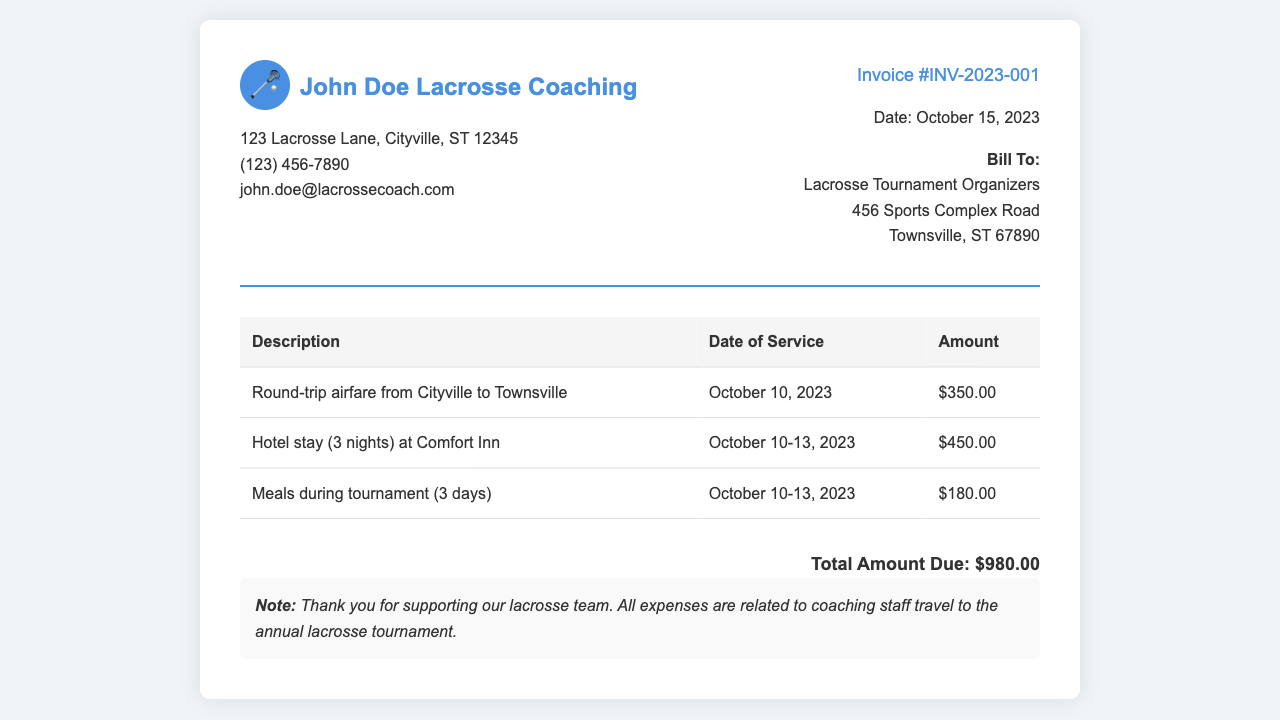What is the invoice number? The invoice number is listed near the top of the document, under the invoice details section.
Answer: INV-2023-001 What is the total amount due? The total amount due is found at the bottom of the invoice document, summarizing all expenses.
Answer: $980.00 Who is the invoice billed to? The billing information is provided in the "Bill To" section, indicating the recipient of the invoice.
Answer: Lacrosse Tournament Organizers What are the dates of service for the hotel stay? The dates of service for the hotel stay are detailed in the description of the accommodation expense.
Answer: October 10-13, 2023 How much was spent on meals? The amount spent on meals is detailed in the table, indicating costs associated with food during the tournament.
Answer: $180.00 What type of document is this? This document is categorized based on its content and intent, summarizing expenses incurred.
Answer: Invoice When was the invoice issued? The issue date of the invoice is noted in the invoice details section, specifying when the charge was created.
Answer: October 15, 2023 How many nights was the hotel stay? The duration of the hotel stay is indicated alongside the hotel expense in the invoice.
Answer: 3 nights What transportation was used? The terms describing the types of transport used for the trip can be found in the expense table.
Answer: Round-trip airfare 